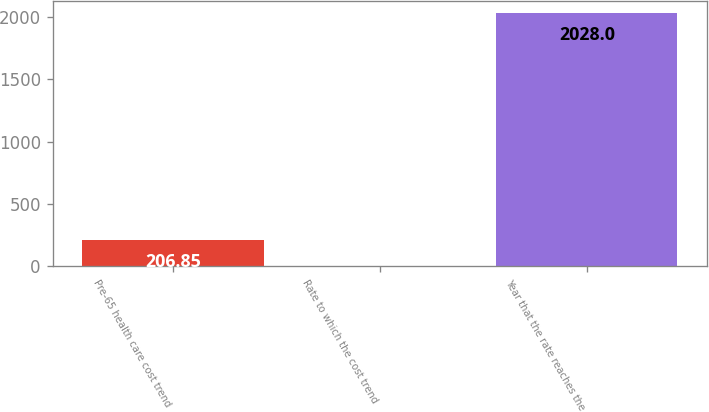Convert chart to OTSL. <chart><loc_0><loc_0><loc_500><loc_500><bar_chart><fcel>Pre-65 health care cost trend<fcel>Rate to which the cost trend<fcel>Year that the rate reaches the<nl><fcel>206.85<fcel>4.5<fcel>2028<nl></chart> 